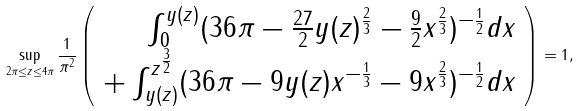Convert formula to latex. <formula><loc_0><loc_0><loc_500><loc_500>\sup _ { 2 \pi \leq z \leq 4 \pi } \frac { 1 } { \pi ^ { 2 } } \left ( \begin{array} { r r } \int _ { 0 } ^ { y ( z ) } ( 3 6 \pi - \frac { 2 7 } { 2 } y ( z ) ^ { \frac { 2 } { 3 } } - \frac { 9 } { 2 } x ^ { \frac { 2 } { 3 } } ) ^ { - \frac { 1 } { 2 } } d x \\ + \int _ { y ( z ) } ^ { z ^ { \frac { 3 } { 2 } } } ( 3 6 \pi - 9 y ( z ) x ^ { - \frac { 1 } { 3 } } - 9 x ^ { \frac { 2 } { 3 } } ) ^ { - \frac { 1 } { 2 } } d x \end{array} \right ) = 1 ,</formula> 